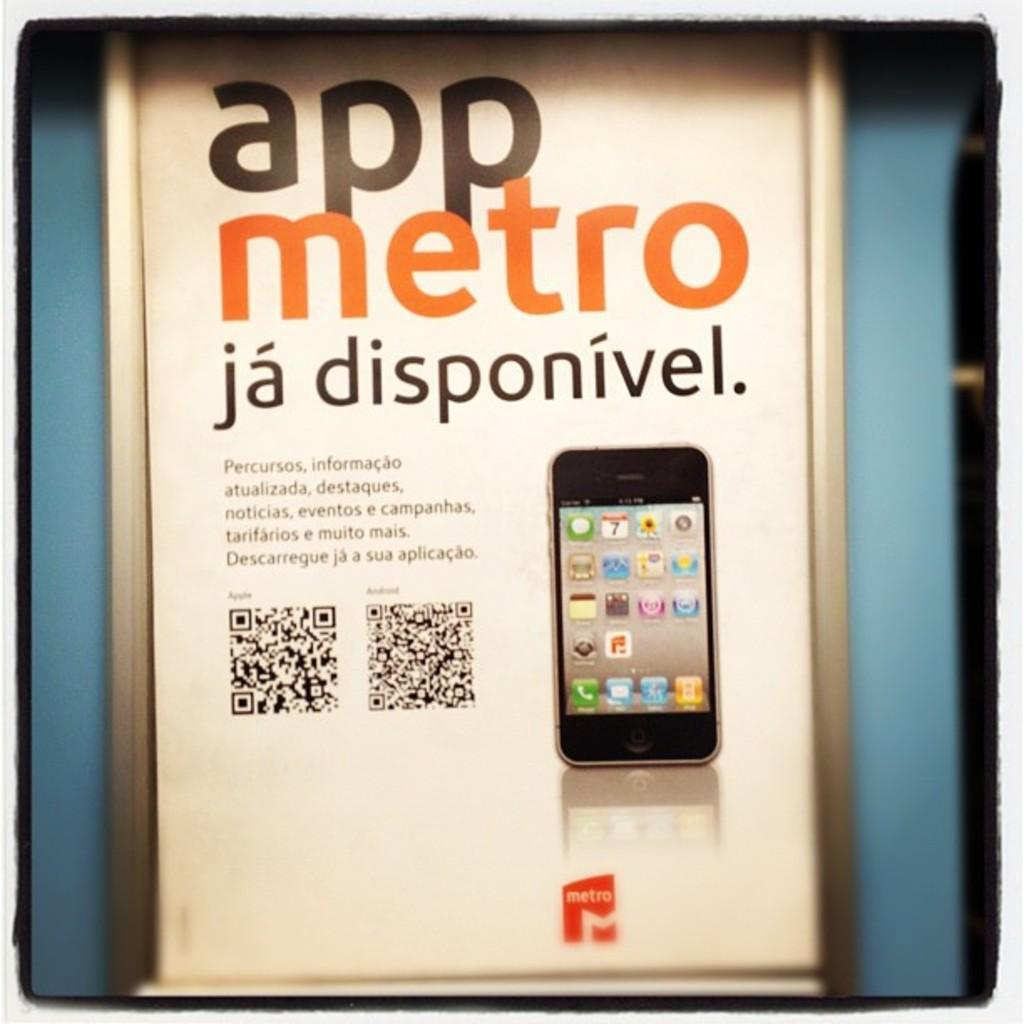<image>
Provide a brief description of the given image. An iPhone is on a poster that says app metro ja disponivel. 